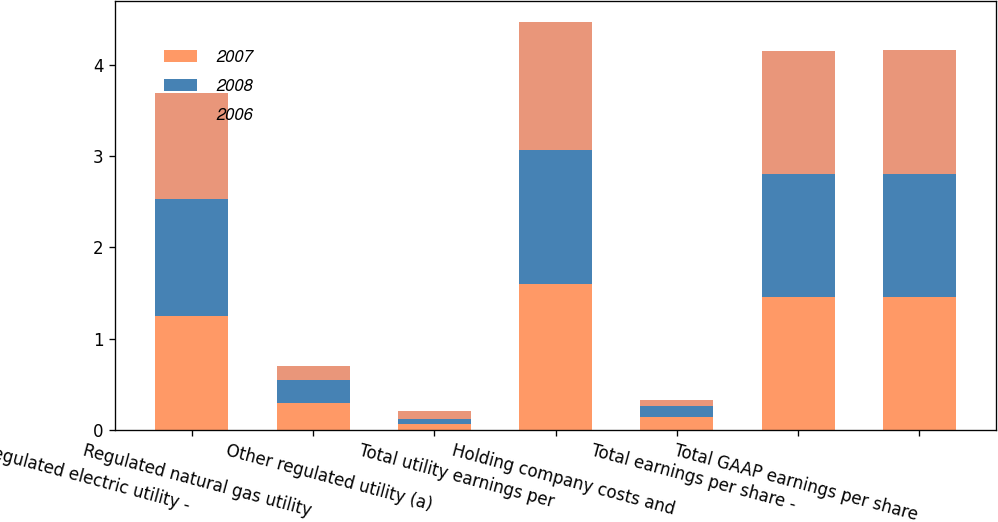Convert chart to OTSL. <chart><loc_0><loc_0><loc_500><loc_500><stacked_bar_chart><ecel><fcel>Regulated electric utility -<fcel>Regulated natural gas utility<fcel>Other regulated utility (a)<fcel>Total utility earnings per<fcel>Holding company costs and<fcel>Total earnings per share -<fcel>Total GAAP earnings per share<nl><fcel>2007<fcel>1.25<fcel>0.29<fcel>0.06<fcel>1.6<fcel>0.14<fcel>1.46<fcel>1.46<nl><fcel>2008<fcel>1.28<fcel>0.25<fcel>0.06<fcel>1.47<fcel>0.12<fcel>1.35<fcel>1.35<nl><fcel>2006<fcel>1.17<fcel>0.16<fcel>0.08<fcel>1.41<fcel>0.06<fcel>1.35<fcel>1.36<nl></chart> 